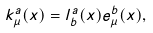Convert formula to latex. <formula><loc_0><loc_0><loc_500><loc_500>k ^ { a } _ { \mu } ( x ) = l ^ { a } _ { b } ( x ) e ^ { b } _ { \mu } ( x ) ,</formula> 